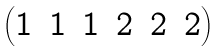<formula> <loc_0><loc_0><loc_500><loc_500>\begin{pmatrix} 1 & 1 & 1 & 2 & 2 & 2 \end{pmatrix}</formula> 